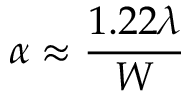<formula> <loc_0><loc_0><loc_500><loc_500>\alpha \approx { \frac { 1 . 2 2 \lambda } { W } }</formula> 